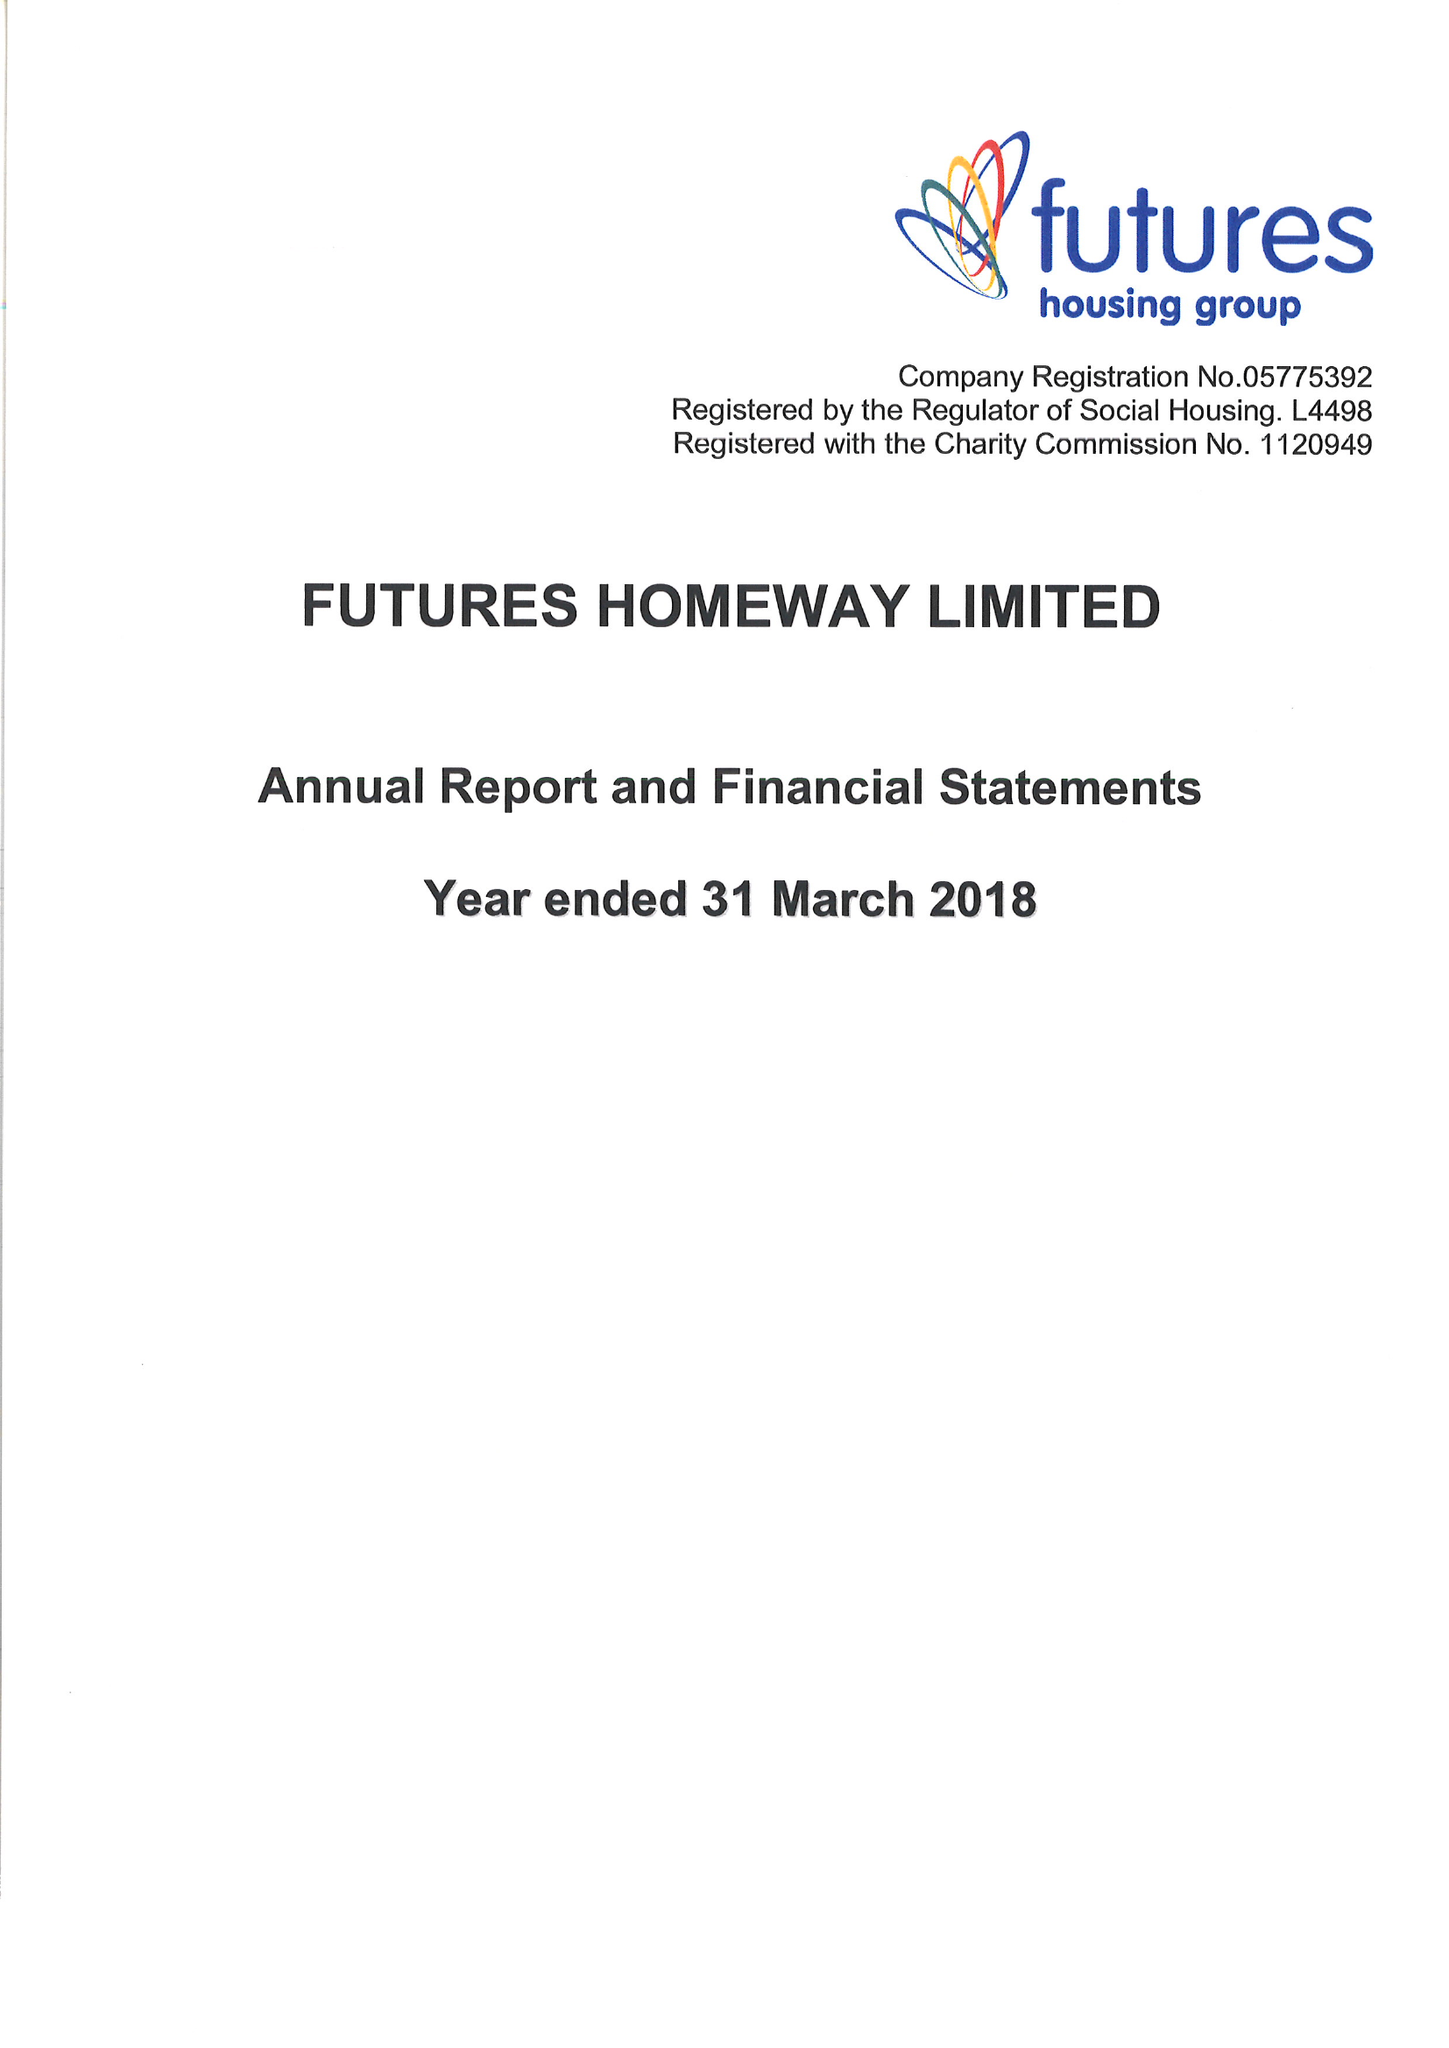What is the value for the address__postcode?
Answer the question using a single word or phrase. DE5 3SW 